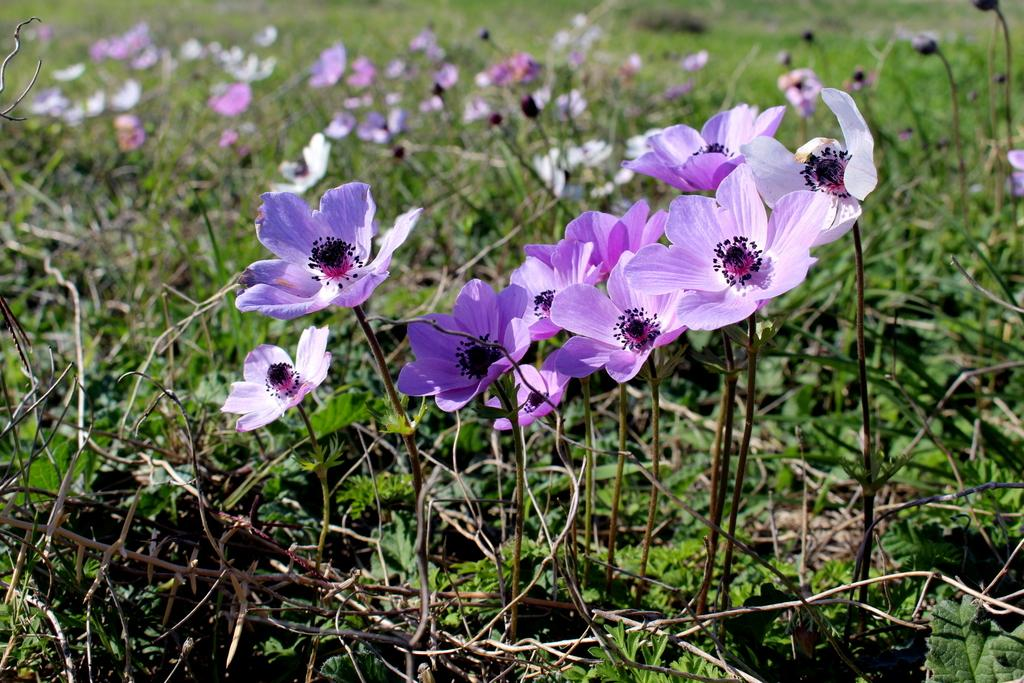What covers the ground in the image? The ground is covered with plants. What type of plants can be seen on the ground? Flowers are present on the ground. What type of pies are being served for lunch in the image? There is no mention of pies or lunch in the image; it only shows plants and flowers on the ground. 